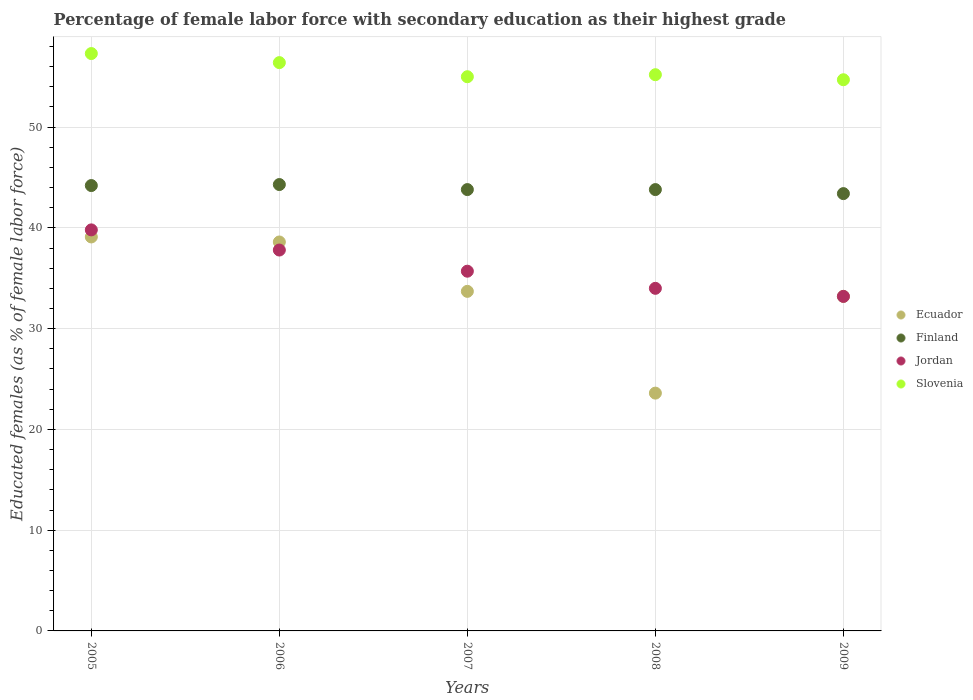How many different coloured dotlines are there?
Provide a succinct answer. 4. Is the number of dotlines equal to the number of legend labels?
Provide a succinct answer. Yes. What is the percentage of female labor force with secondary education in Jordan in 2005?
Provide a short and direct response. 39.8. Across all years, what is the maximum percentage of female labor force with secondary education in Finland?
Provide a short and direct response. 44.3. Across all years, what is the minimum percentage of female labor force with secondary education in Finland?
Provide a short and direct response. 43.4. What is the total percentage of female labor force with secondary education in Finland in the graph?
Offer a very short reply. 219.5. What is the difference between the percentage of female labor force with secondary education in Finland in 2008 and that in 2009?
Ensure brevity in your answer.  0.4. What is the difference between the percentage of female labor force with secondary education in Finland in 2008 and the percentage of female labor force with secondary education in Jordan in 2009?
Make the answer very short. 10.6. What is the average percentage of female labor force with secondary education in Finland per year?
Ensure brevity in your answer.  43.9. In the year 2008, what is the difference between the percentage of female labor force with secondary education in Finland and percentage of female labor force with secondary education in Ecuador?
Your response must be concise. 20.2. What is the ratio of the percentage of female labor force with secondary education in Ecuador in 2007 to that in 2009?
Offer a very short reply. 1.02. What is the difference between the highest and the lowest percentage of female labor force with secondary education in Ecuador?
Your answer should be very brief. 15.5. Is the percentage of female labor force with secondary education in Ecuador strictly greater than the percentage of female labor force with secondary education in Slovenia over the years?
Give a very brief answer. No. Is the percentage of female labor force with secondary education in Slovenia strictly less than the percentage of female labor force with secondary education in Jordan over the years?
Provide a short and direct response. No. How many dotlines are there?
Ensure brevity in your answer.  4. How many years are there in the graph?
Your response must be concise. 5. What is the difference between two consecutive major ticks on the Y-axis?
Make the answer very short. 10. Does the graph contain any zero values?
Offer a terse response. No. Where does the legend appear in the graph?
Your response must be concise. Center right. How many legend labels are there?
Your response must be concise. 4. What is the title of the graph?
Provide a succinct answer. Percentage of female labor force with secondary education as their highest grade. Does "New Zealand" appear as one of the legend labels in the graph?
Offer a terse response. No. What is the label or title of the X-axis?
Provide a succinct answer. Years. What is the label or title of the Y-axis?
Your answer should be very brief. Educated females (as % of female labor force). What is the Educated females (as % of female labor force) of Ecuador in 2005?
Provide a succinct answer. 39.1. What is the Educated females (as % of female labor force) in Finland in 2005?
Your answer should be very brief. 44.2. What is the Educated females (as % of female labor force) in Jordan in 2005?
Your answer should be very brief. 39.8. What is the Educated females (as % of female labor force) of Slovenia in 2005?
Give a very brief answer. 57.3. What is the Educated females (as % of female labor force) of Ecuador in 2006?
Make the answer very short. 38.6. What is the Educated females (as % of female labor force) of Finland in 2006?
Your response must be concise. 44.3. What is the Educated females (as % of female labor force) of Jordan in 2006?
Your response must be concise. 37.8. What is the Educated females (as % of female labor force) in Slovenia in 2006?
Make the answer very short. 56.4. What is the Educated females (as % of female labor force) of Ecuador in 2007?
Offer a very short reply. 33.7. What is the Educated females (as % of female labor force) of Finland in 2007?
Offer a terse response. 43.8. What is the Educated females (as % of female labor force) in Jordan in 2007?
Offer a terse response. 35.7. What is the Educated females (as % of female labor force) in Ecuador in 2008?
Your response must be concise. 23.6. What is the Educated females (as % of female labor force) of Finland in 2008?
Provide a short and direct response. 43.8. What is the Educated females (as % of female labor force) of Jordan in 2008?
Offer a very short reply. 34. What is the Educated females (as % of female labor force) in Slovenia in 2008?
Make the answer very short. 55.2. What is the Educated females (as % of female labor force) in Ecuador in 2009?
Give a very brief answer. 33.2. What is the Educated females (as % of female labor force) in Finland in 2009?
Make the answer very short. 43.4. What is the Educated females (as % of female labor force) in Jordan in 2009?
Offer a terse response. 33.2. What is the Educated females (as % of female labor force) in Slovenia in 2009?
Provide a succinct answer. 54.7. Across all years, what is the maximum Educated females (as % of female labor force) in Ecuador?
Your answer should be compact. 39.1. Across all years, what is the maximum Educated females (as % of female labor force) in Finland?
Your answer should be very brief. 44.3. Across all years, what is the maximum Educated females (as % of female labor force) of Jordan?
Your answer should be compact. 39.8. Across all years, what is the maximum Educated females (as % of female labor force) in Slovenia?
Your answer should be very brief. 57.3. Across all years, what is the minimum Educated females (as % of female labor force) in Ecuador?
Make the answer very short. 23.6. Across all years, what is the minimum Educated females (as % of female labor force) in Finland?
Your response must be concise. 43.4. Across all years, what is the minimum Educated females (as % of female labor force) of Jordan?
Give a very brief answer. 33.2. Across all years, what is the minimum Educated females (as % of female labor force) of Slovenia?
Your answer should be very brief. 54.7. What is the total Educated females (as % of female labor force) of Ecuador in the graph?
Provide a succinct answer. 168.2. What is the total Educated females (as % of female labor force) of Finland in the graph?
Provide a succinct answer. 219.5. What is the total Educated females (as % of female labor force) in Jordan in the graph?
Make the answer very short. 180.5. What is the total Educated females (as % of female labor force) of Slovenia in the graph?
Offer a very short reply. 278.6. What is the difference between the Educated females (as % of female labor force) of Finland in 2005 and that in 2006?
Your response must be concise. -0.1. What is the difference between the Educated females (as % of female labor force) of Jordan in 2005 and that in 2006?
Provide a succinct answer. 2. What is the difference between the Educated females (as % of female labor force) of Ecuador in 2005 and that in 2007?
Provide a short and direct response. 5.4. What is the difference between the Educated females (as % of female labor force) in Slovenia in 2005 and that in 2007?
Give a very brief answer. 2.3. What is the difference between the Educated females (as % of female labor force) in Jordan in 2005 and that in 2008?
Make the answer very short. 5.8. What is the difference between the Educated females (as % of female labor force) in Jordan in 2005 and that in 2009?
Make the answer very short. 6.6. What is the difference between the Educated females (as % of female labor force) in Ecuador in 2006 and that in 2007?
Your answer should be compact. 4.9. What is the difference between the Educated females (as % of female labor force) in Jordan in 2006 and that in 2007?
Your response must be concise. 2.1. What is the difference between the Educated females (as % of female labor force) in Ecuador in 2006 and that in 2008?
Your answer should be very brief. 15. What is the difference between the Educated females (as % of female labor force) of Finland in 2006 and that in 2008?
Your response must be concise. 0.5. What is the difference between the Educated females (as % of female labor force) of Slovenia in 2006 and that in 2008?
Make the answer very short. 1.2. What is the difference between the Educated females (as % of female labor force) in Ecuador in 2006 and that in 2009?
Offer a terse response. 5.4. What is the difference between the Educated females (as % of female labor force) of Finland in 2006 and that in 2009?
Your response must be concise. 0.9. What is the difference between the Educated females (as % of female labor force) of Slovenia in 2006 and that in 2009?
Your answer should be compact. 1.7. What is the difference between the Educated females (as % of female labor force) of Ecuador in 2007 and that in 2008?
Keep it short and to the point. 10.1. What is the difference between the Educated females (as % of female labor force) of Jordan in 2007 and that in 2009?
Your answer should be very brief. 2.5. What is the difference between the Educated females (as % of female labor force) of Finland in 2008 and that in 2009?
Your answer should be compact. 0.4. What is the difference between the Educated females (as % of female labor force) in Ecuador in 2005 and the Educated females (as % of female labor force) in Finland in 2006?
Your response must be concise. -5.2. What is the difference between the Educated females (as % of female labor force) in Ecuador in 2005 and the Educated females (as % of female labor force) in Slovenia in 2006?
Offer a very short reply. -17.3. What is the difference between the Educated females (as % of female labor force) of Finland in 2005 and the Educated females (as % of female labor force) of Jordan in 2006?
Your response must be concise. 6.4. What is the difference between the Educated females (as % of female labor force) of Finland in 2005 and the Educated females (as % of female labor force) of Slovenia in 2006?
Offer a terse response. -12.2. What is the difference between the Educated females (as % of female labor force) of Jordan in 2005 and the Educated females (as % of female labor force) of Slovenia in 2006?
Give a very brief answer. -16.6. What is the difference between the Educated females (as % of female labor force) in Ecuador in 2005 and the Educated females (as % of female labor force) in Finland in 2007?
Your answer should be compact. -4.7. What is the difference between the Educated females (as % of female labor force) of Ecuador in 2005 and the Educated females (as % of female labor force) of Slovenia in 2007?
Your answer should be very brief. -15.9. What is the difference between the Educated females (as % of female labor force) of Jordan in 2005 and the Educated females (as % of female labor force) of Slovenia in 2007?
Give a very brief answer. -15.2. What is the difference between the Educated females (as % of female labor force) of Ecuador in 2005 and the Educated females (as % of female labor force) of Slovenia in 2008?
Your answer should be compact. -16.1. What is the difference between the Educated females (as % of female labor force) in Finland in 2005 and the Educated females (as % of female labor force) in Jordan in 2008?
Offer a terse response. 10.2. What is the difference between the Educated females (as % of female labor force) in Finland in 2005 and the Educated females (as % of female labor force) in Slovenia in 2008?
Keep it short and to the point. -11. What is the difference between the Educated females (as % of female labor force) in Jordan in 2005 and the Educated females (as % of female labor force) in Slovenia in 2008?
Your response must be concise. -15.4. What is the difference between the Educated females (as % of female labor force) of Ecuador in 2005 and the Educated females (as % of female labor force) of Finland in 2009?
Provide a succinct answer. -4.3. What is the difference between the Educated females (as % of female labor force) of Ecuador in 2005 and the Educated females (as % of female labor force) of Jordan in 2009?
Ensure brevity in your answer.  5.9. What is the difference between the Educated females (as % of female labor force) in Ecuador in 2005 and the Educated females (as % of female labor force) in Slovenia in 2009?
Ensure brevity in your answer.  -15.6. What is the difference between the Educated females (as % of female labor force) in Finland in 2005 and the Educated females (as % of female labor force) in Jordan in 2009?
Your response must be concise. 11. What is the difference between the Educated females (as % of female labor force) of Jordan in 2005 and the Educated females (as % of female labor force) of Slovenia in 2009?
Ensure brevity in your answer.  -14.9. What is the difference between the Educated females (as % of female labor force) of Ecuador in 2006 and the Educated females (as % of female labor force) of Slovenia in 2007?
Offer a terse response. -16.4. What is the difference between the Educated females (as % of female labor force) of Finland in 2006 and the Educated females (as % of female labor force) of Slovenia in 2007?
Provide a short and direct response. -10.7. What is the difference between the Educated females (as % of female labor force) of Jordan in 2006 and the Educated females (as % of female labor force) of Slovenia in 2007?
Keep it short and to the point. -17.2. What is the difference between the Educated females (as % of female labor force) of Ecuador in 2006 and the Educated females (as % of female labor force) of Jordan in 2008?
Offer a terse response. 4.6. What is the difference between the Educated females (as % of female labor force) of Ecuador in 2006 and the Educated females (as % of female labor force) of Slovenia in 2008?
Ensure brevity in your answer.  -16.6. What is the difference between the Educated females (as % of female labor force) of Finland in 2006 and the Educated females (as % of female labor force) of Slovenia in 2008?
Your answer should be very brief. -10.9. What is the difference between the Educated females (as % of female labor force) in Jordan in 2006 and the Educated females (as % of female labor force) in Slovenia in 2008?
Your answer should be very brief. -17.4. What is the difference between the Educated females (as % of female labor force) in Ecuador in 2006 and the Educated females (as % of female labor force) in Slovenia in 2009?
Keep it short and to the point. -16.1. What is the difference between the Educated females (as % of female labor force) in Jordan in 2006 and the Educated females (as % of female labor force) in Slovenia in 2009?
Make the answer very short. -16.9. What is the difference between the Educated females (as % of female labor force) of Ecuador in 2007 and the Educated females (as % of female labor force) of Finland in 2008?
Provide a succinct answer. -10.1. What is the difference between the Educated females (as % of female labor force) of Ecuador in 2007 and the Educated females (as % of female labor force) of Slovenia in 2008?
Ensure brevity in your answer.  -21.5. What is the difference between the Educated females (as % of female labor force) in Finland in 2007 and the Educated females (as % of female labor force) in Jordan in 2008?
Give a very brief answer. 9.8. What is the difference between the Educated females (as % of female labor force) in Jordan in 2007 and the Educated females (as % of female labor force) in Slovenia in 2008?
Your answer should be compact. -19.5. What is the difference between the Educated females (as % of female labor force) of Ecuador in 2007 and the Educated females (as % of female labor force) of Jordan in 2009?
Make the answer very short. 0.5. What is the difference between the Educated females (as % of female labor force) of Finland in 2007 and the Educated females (as % of female labor force) of Slovenia in 2009?
Give a very brief answer. -10.9. What is the difference between the Educated females (as % of female labor force) of Ecuador in 2008 and the Educated females (as % of female labor force) of Finland in 2009?
Your answer should be compact. -19.8. What is the difference between the Educated females (as % of female labor force) of Ecuador in 2008 and the Educated females (as % of female labor force) of Jordan in 2009?
Provide a short and direct response. -9.6. What is the difference between the Educated females (as % of female labor force) in Ecuador in 2008 and the Educated females (as % of female labor force) in Slovenia in 2009?
Offer a terse response. -31.1. What is the difference between the Educated females (as % of female labor force) of Jordan in 2008 and the Educated females (as % of female labor force) of Slovenia in 2009?
Your response must be concise. -20.7. What is the average Educated females (as % of female labor force) of Ecuador per year?
Offer a terse response. 33.64. What is the average Educated females (as % of female labor force) in Finland per year?
Ensure brevity in your answer.  43.9. What is the average Educated females (as % of female labor force) of Jordan per year?
Offer a terse response. 36.1. What is the average Educated females (as % of female labor force) in Slovenia per year?
Make the answer very short. 55.72. In the year 2005, what is the difference between the Educated females (as % of female labor force) in Ecuador and Educated females (as % of female labor force) in Finland?
Provide a short and direct response. -5.1. In the year 2005, what is the difference between the Educated females (as % of female labor force) of Ecuador and Educated females (as % of female labor force) of Slovenia?
Offer a very short reply. -18.2. In the year 2005, what is the difference between the Educated females (as % of female labor force) of Finland and Educated females (as % of female labor force) of Jordan?
Provide a succinct answer. 4.4. In the year 2005, what is the difference between the Educated females (as % of female labor force) of Jordan and Educated females (as % of female labor force) of Slovenia?
Keep it short and to the point. -17.5. In the year 2006, what is the difference between the Educated females (as % of female labor force) in Ecuador and Educated females (as % of female labor force) in Jordan?
Your answer should be compact. 0.8. In the year 2006, what is the difference between the Educated females (as % of female labor force) of Ecuador and Educated females (as % of female labor force) of Slovenia?
Your answer should be compact. -17.8. In the year 2006, what is the difference between the Educated females (as % of female labor force) of Jordan and Educated females (as % of female labor force) of Slovenia?
Keep it short and to the point. -18.6. In the year 2007, what is the difference between the Educated females (as % of female labor force) in Ecuador and Educated females (as % of female labor force) in Finland?
Provide a succinct answer. -10.1. In the year 2007, what is the difference between the Educated females (as % of female labor force) of Ecuador and Educated females (as % of female labor force) of Slovenia?
Your answer should be very brief. -21.3. In the year 2007, what is the difference between the Educated females (as % of female labor force) of Finland and Educated females (as % of female labor force) of Jordan?
Offer a very short reply. 8.1. In the year 2007, what is the difference between the Educated females (as % of female labor force) in Jordan and Educated females (as % of female labor force) in Slovenia?
Provide a succinct answer. -19.3. In the year 2008, what is the difference between the Educated females (as % of female labor force) in Ecuador and Educated females (as % of female labor force) in Finland?
Offer a very short reply. -20.2. In the year 2008, what is the difference between the Educated females (as % of female labor force) of Ecuador and Educated females (as % of female labor force) of Slovenia?
Your response must be concise. -31.6. In the year 2008, what is the difference between the Educated females (as % of female labor force) in Finland and Educated females (as % of female labor force) in Jordan?
Offer a very short reply. 9.8. In the year 2008, what is the difference between the Educated females (as % of female labor force) of Jordan and Educated females (as % of female labor force) of Slovenia?
Offer a very short reply. -21.2. In the year 2009, what is the difference between the Educated females (as % of female labor force) in Ecuador and Educated females (as % of female labor force) in Slovenia?
Your response must be concise. -21.5. In the year 2009, what is the difference between the Educated females (as % of female labor force) of Finland and Educated females (as % of female labor force) of Slovenia?
Your response must be concise. -11.3. In the year 2009, what is the difference between the Educated females (as % of female labor force) of Jordan and Educated females (as % of female labor force) of Slovenia?
Provide a succinct answer. -21.5. What is the ratio of the Educated females (as % of female labor force) in Ecuador in 2005 to that in 2006?
Offer a terse response. 1.01. What is the ratio of the Educated females (as % of female labor force) of Jordan in 2005 to that in 2006?
Your answer should be compact. 1.05. What is the ratio of the Educated females (as % of female labor force) of Ecuador in 2005 to that in 2007?
Your response must be concise. 1.16. What is the ratio of the Educated females (as % of female labor force) in Finland in 2005 to that in 2007?
Your response must be concise. 1.01. What is the ratio of the Educated females (as % of female labor force) of Jordan in 2005 to that in 2007?
Make the answer very short. 1.11. What is the ratio of the Educated females (as % of female labor force) of Slovenia in 2005 to that in 2007?
Offer a terse response. 1.04. What is the ratio of the Educated females (as % of female labor force) of Ecuador in 2005 to that in 2008?
Ensure brevity in your answer.  1.66. What is the ratio of the Educated females (as % of female labor force) in Finland in 2005 to that in 2008?
Provide a short and direct response. 1.01. What is the ratio of the Educated females (as % of female labor force) in Jordan in 2005 to that in 2008?
Keep it short and to the point. 1.17. What is the ratio of the Educated females (as % of female labor force) of Slovenia in 2005 to that in 2008?
Offer a very short reply. 1.04. What is the ratio of the Educated females (as % of female labor force) in Ecuador in 2005 to that in 2009?
Ensure brevity in your answer.  1.18. What is the ratio of the Educated females (as % of female labor force) in Finland in 2005 to that in 2009?
Keep it short and to the point. 1.02. What is the ratio of the Educated females (as % of female labor force) of Jordan in 2005 to that in 2009?
Provide a short and direct response. 1.2. What is the ratio of the Educated females (as % of female labor force) of Slovenia in 2005 to that in 2009?
Keep it short and to the point. 1.05. What is the ratio of the Educated females (as % of female labor force) of Ecuador in 2006 to that in 2007?
Give a very brief answer. 1.15. What is the ratio of the Educated females (as % of female labor force) in Finland in 2006 to that in 2007?
Your answer should be very brief. 1.01. What is the ratio of the Educated females (as % of female labor force) of Jordan in 2006 to that in 2007?
Your response must be concise. 1.06. What is the ratio of the Educated females (as % of female labor force) of Slovenia in 2006 to that in 2007?
Provide a succinct answer. 1.03. What is the ratio of the Educated females (as % of female labor force) of Ecuador in 2006 to that in 2008?
Offer a very short reply. 1.64. What is the ratio of the Educated females (as % of female labor force) in Finland in 2006 to that in 2008?
Your response must be concise. 1.01. What is the ratio of the Educated females (as % of female labor force) of Jordan in 2006 to that in 2008?
Make the answer very short. 1.11. What is the ratio of the Educated females (as % of female labor force) of Slovenia in 2006 to that in 2008?
Give a very brief answer. 1.02. What is the ratio of the Educated females (as % of female labor force) of Ecuador in 2006 to that in 2009?
Offer a very short reply. 1.16. What is the ratio of the Educated females (as % of female labor force) in Finland in 2006 to that in 2009?
Offer a very short reply. 1.02. What is the ratio of the Educated females (as % of female labor force) of Jordan in 2006 to that in 2009?
Keep it short and to the point. 1.14. What is the ratio of the Educated females (as % of female labor force) of Slovenia in 2006 to that in 2009?
Your answer should be very brief. 1.03. What is the ratio of the Educated females (as % of female labor force) in Ecuador in 2007 to that in 2008?
Keep it short and to the point. 1.43. What is the ratio of the Educated females (as % of female labor force) of Finland in 2007 to that in 2008?
Provide a succinct answer. 1. What is the ratio of the Educated females (as % of female labor force) in Ecuador in 2007 to that in 2009?
Your answer should be compact. 1.02. What is the ratio of the Educated females (as % of female labor force) in Finland in 2007 to that in 2009?
Make the answer very short. 1.01. What is the ratio of the Educated females (as % of female labor force) in Jordan in 2007 to that in 2009?
Your answer should be very brief. 1.08. What is the ratio of the Educated females (as % of female labor force) in Ecuador in 2008 to that in 2009?
Offer a very short reply. 0.71. What is the ratio of the Educated females (as % of female labor force) in Finland in 2008 to that in 2009?
Give a very brief answer. 1.01. What is the ratio of the Educated females (as % of female labor force) of Jordan in 2008 to that in 2009?
Your answer should be very brief. 1.02. What is the ratio of the Educated females (as % of female labor force) of Slovenia in 2008 to that in 2009?
Your response must be concise. 1.01. What is the difference between the highest and the second highest Educated females (as % of female labor force) of Ecuador?
Your answer should be compact. 0.5. What is the difference between the highest and the second highest Educated females (as % of female labor force) of Slovenia?
Give a very brief answer. 0.9. What is the difference between the highest and the lowest Educated females (as % of female labor force) of Ecuador?
Give a very brief answer. 15.5. What is the difference between the highest and the lowest Educated females (as % of female labor force) of Jordan?
Give a very brief answer. 6.6. 